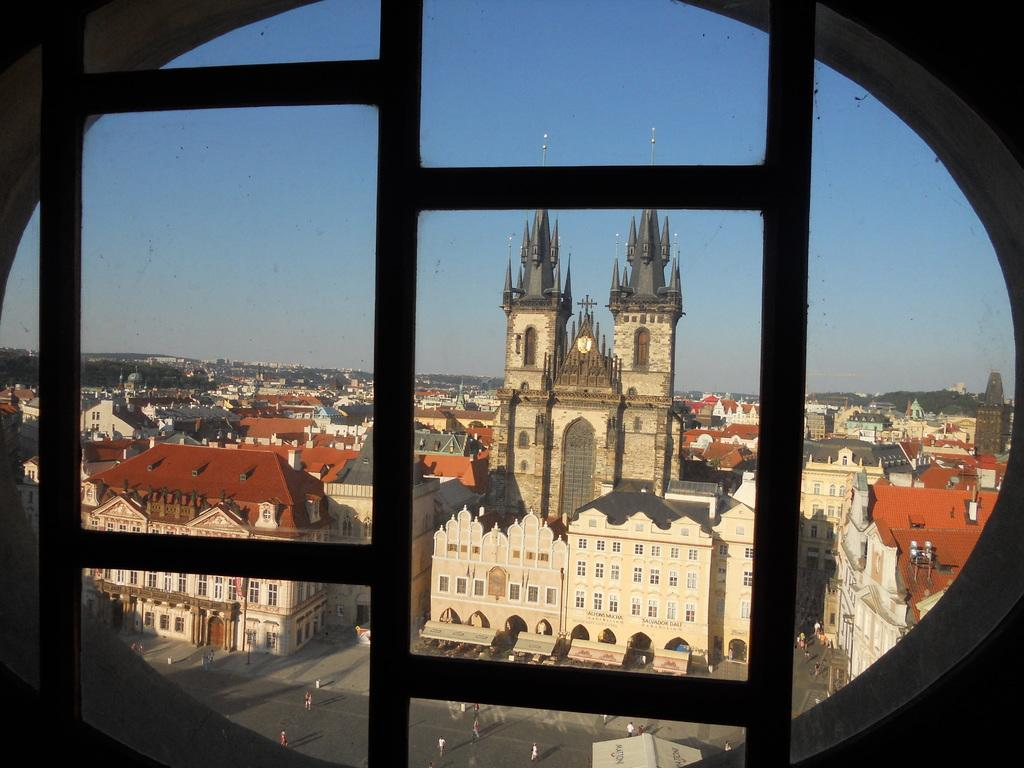What type of structures can be seen in the image? There are buildings in the image. What other natural elements are present in the image? There are trees in the image. Are there any living beings visible in the image? Yes, there are people in the image. What can be seen in the distance in the image? The sky is visible in the background of the image. What type of lunchroom is located in the image? There is no mention of a lunchroom in the image; it features buildings, trees, people, and the sky. How hot is the temperature in the image? The temperature cannot be determined from the image, as it only provides visual information. 